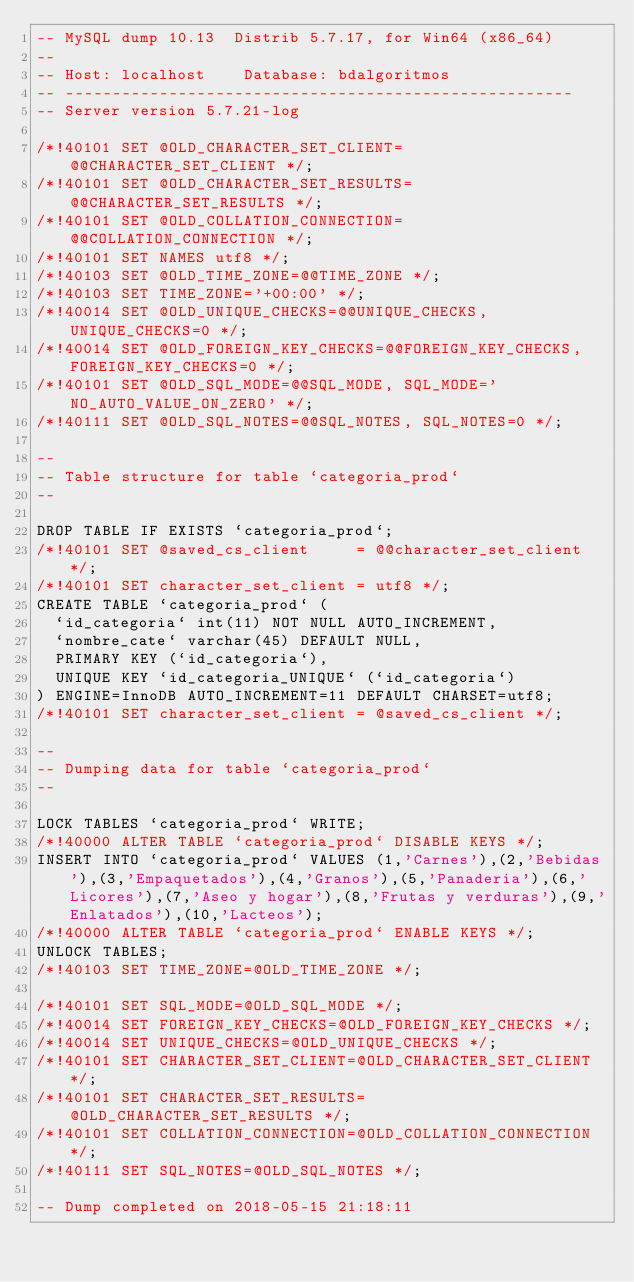<code> <loc_0><loc_0><loc_500><loc_500><_SQL_>-- MySQL dump 10.13  Distrib 5.7.17, for Win64 (x86_64)
--
-- Host: localhost    Database: bdalgoritmos
-- ------------------------------------------------------
-- Server version	5.7.21-log

/*!40101 SET @OLD_CHARACTER_SET_CLIENT=@@CHARACTER_SET_CLIENT */;
/*!40101 SET @OLD_CHARACTER_SET_RESULTS=@@CHARACTER_SET_RESULTS */;
/*!40101 SET @OLD_COLLATION_CONNECTION=@@COLLATION_CONNECTION */;
/*!40101 SET NAMES utf8 */;
/*!40103 SET @OLD_TIME_ZONE=@@TIME_ZONE */;
/*!40103 SET TIME_ZONE='+00:00' */;
/*!40014 SET @OLD_UNIQUE_CHECKS=@@UNIQUE_CHECKS, UNIQUE_CHECKS=0 */;
/*!40014 SET @OLD_FOREIGN_KEY_CHECKS=@@FOREIGN_KEY_CHECKS, FOREIGN_KEY_CHECKS=0 */;
/*!40101 SET @OLD_SQL_MODE=@@SQL_MODE, SQL_MODE='NO_AUTO_VALUE_ON_ZERO' */;
/*!40111 SET @OLD_SQL_NOTES=@@SQL_NOTES, SQL_NOTES=0 */;

--
-- Table structure for table `categoria_prod`
--

DROP TABLE IF EXISTS `categoria_prod`;
/*!40101 SET @saved_cs_client     = @@character_set_client */;
/*!40101 SET character_set_client = utf8 */;
CREATE TABLE `categoria_prod` (
  `id_categoria` int(11) NOT NULL AUTO_INCREMENT,
  `nombre_cate` varchar(45) DEFAULT NULL,
  PRIMARY KEY (`id_categoria`),
  UNIQUE KEY `id_categoria_UNIQUE` (`id_categoria`)
) ENGINE=InnoDB AUTO_INCREMENT=11 DEFAULT CHARSET=utf8;
/*!40101 SET character_set_client = @saved_cs_client */;

--
-- Dumping data for table `categoria_prod`
--

LOCK TABLES `categoria_prod` WRITE;
/*!40000 ALTER TABLE `categoria_prod` DISABLE KEYS */;
INSERT INTO `categoria_prod` VALUES (1,'Carnes'),(2,'Bebidas'),(3,'Empaquetados'),(4,'Granos'),(5,'Panaderia'),(6,'Licores'),(7,'Aseo y hogar'),(8,'Frutas y verduras'),(9,'Enlatados'),(10,'Lacteos');
/*!40000 ALTER TABLE `categoria_prod` ENABLE KEYS */;
UNLOCK TABLES;
/*!40103 SET TIME_ZONE=@OLD_TIME_ZONE */;

/*!40101 SET SQL_MODE=@OLD_SQL_MODE */;
/*!40014 SET FOREIGN_KEY_CHECKS=@OLD_FOREIGN_KEY_CHECKS */;
/*!40014 SET UNIQUE_CHECKS=@OLD_UNIQUE_CHECKS */;
/*!40101 SET CHARACTER_SET_CLIENT=@OLD_CHARACTER_SET_CLIENT */;
/*!40101 SET CHARACTER_SET_RESULTS=@OLD_CHARACTER_SET_RESULTS */;
/*!40101 SET COLLATION_CONNECTION=@OLD_COLLATION_CONNECTION */;
/*!40111 SET SQL_NOTES=@OLD_SQL_NOTES */;

-- Dump completed on 2018-05-15 21:18:11
</code> 